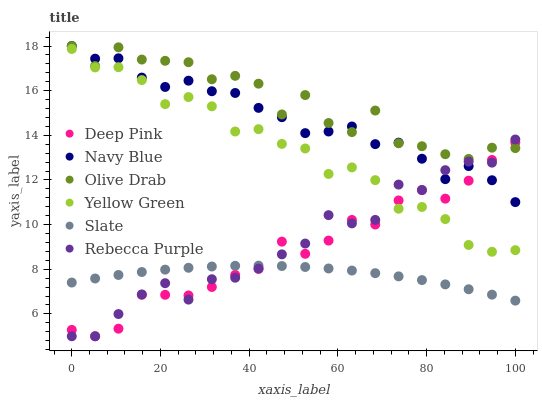Does Slate have the minimum area under the curve?
Answer yes or no. Yes. Does Olive Drab have the maximum area under the curve?
Answer yes or no. Yes. Does Yellow Green have the minimum area under the curve?
Answer yes or no. No. Does Yellow Green have the maximum area under the curve?
Answer yes or no. No. Is Slate the smoothest?
Answer yes or no. Yes. Is Olive Drab the roughest?
Answer yes or no. Yes. Is Yellow Green the smoothest?
Answer yes or no. No. Is Yellow Green the roughest?
Answer yes or no. No. Does Deep Pink have the lowest value?
Answer yes or no. Yes. Does Yellow Green have the lowest value?
Answer yes or no. No. Does Olive Drab have the highest value?
Answer yes or no. Yes. Does Yellow Green have the highest value?
Answer yes or no. No. Is Slate less than Yellow Green?
Answer yes or no. Yes. Is Yellow Green greater than Slate?
Answer yes or no. Yes. Does Deep Pink intersect Olive Drab?
Answer yes or no. Yes. Is Deep Pink less than Olive Drab?
Answer yes or no. No. Is Deep Pink greater than Olive Drab?
Answer yes or no. No. Does Slate intersect Yellow Green?
Answer yes or no. No. 